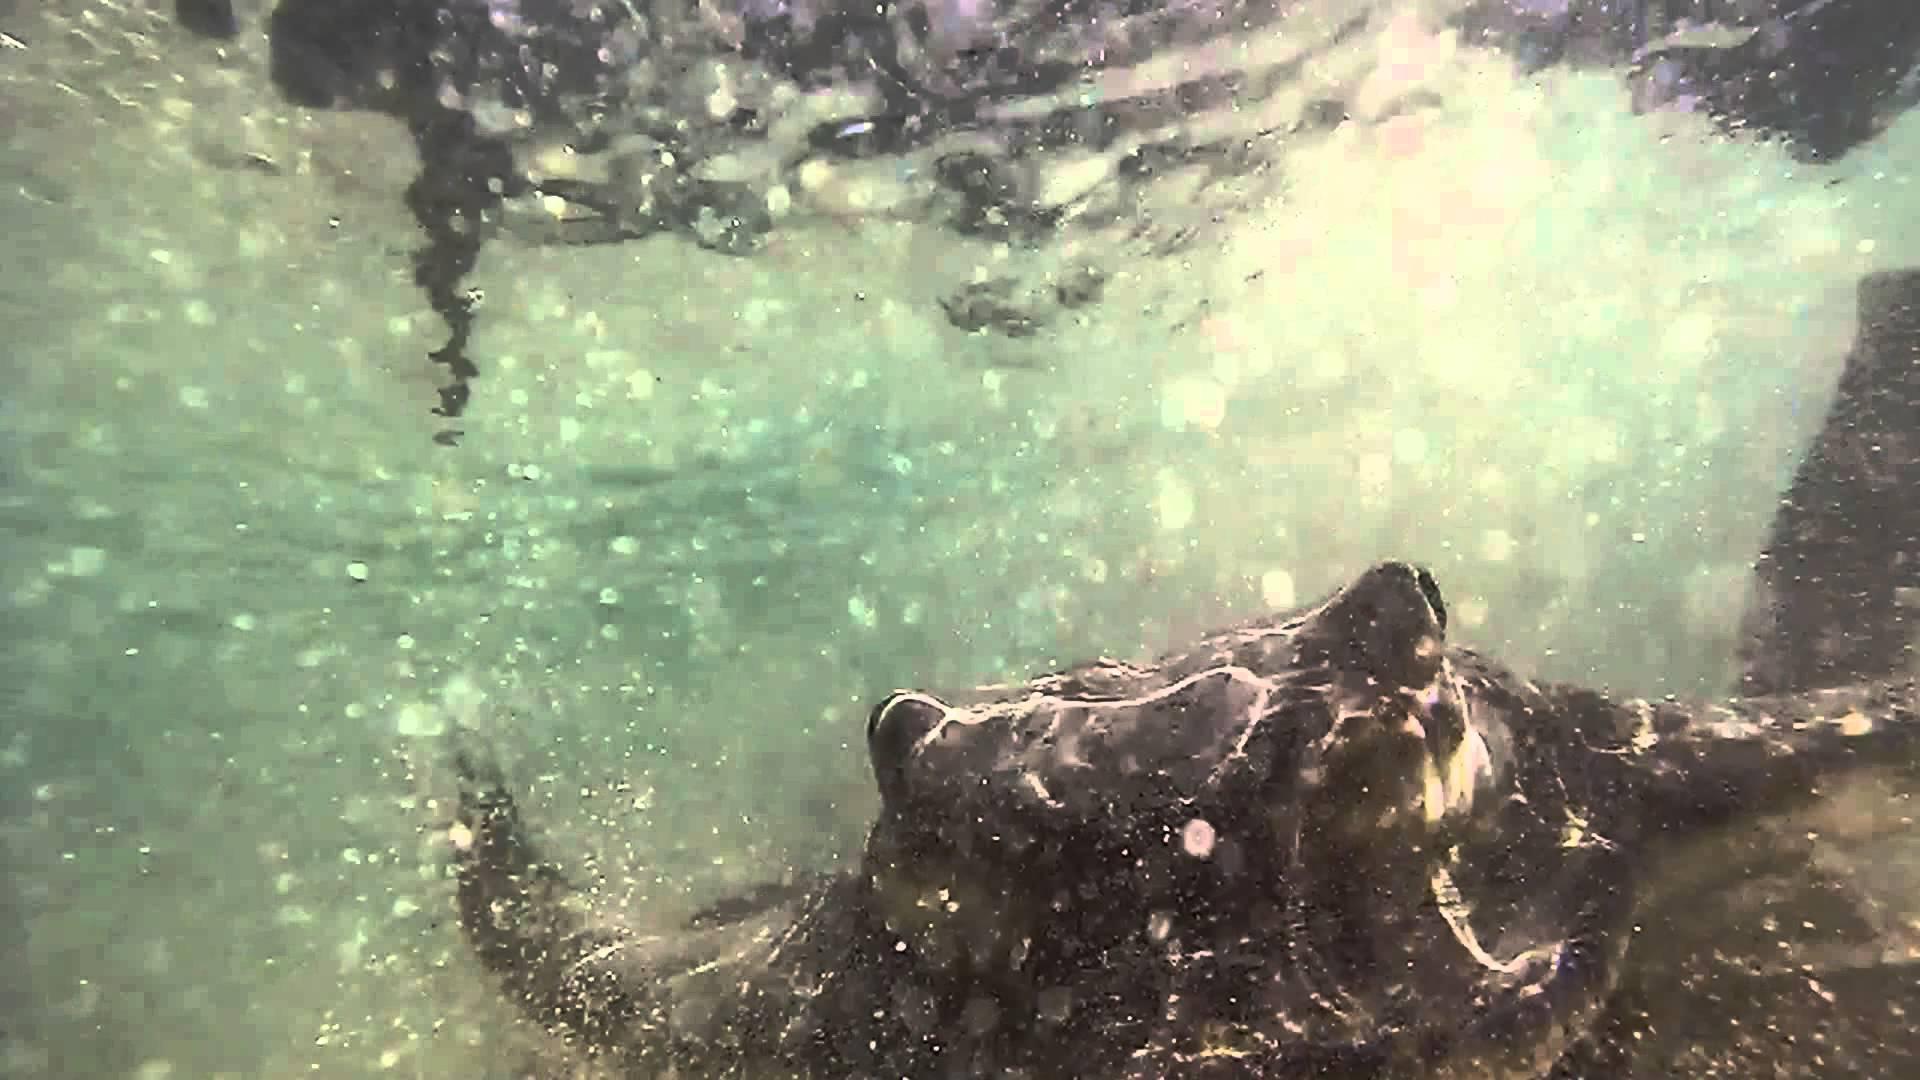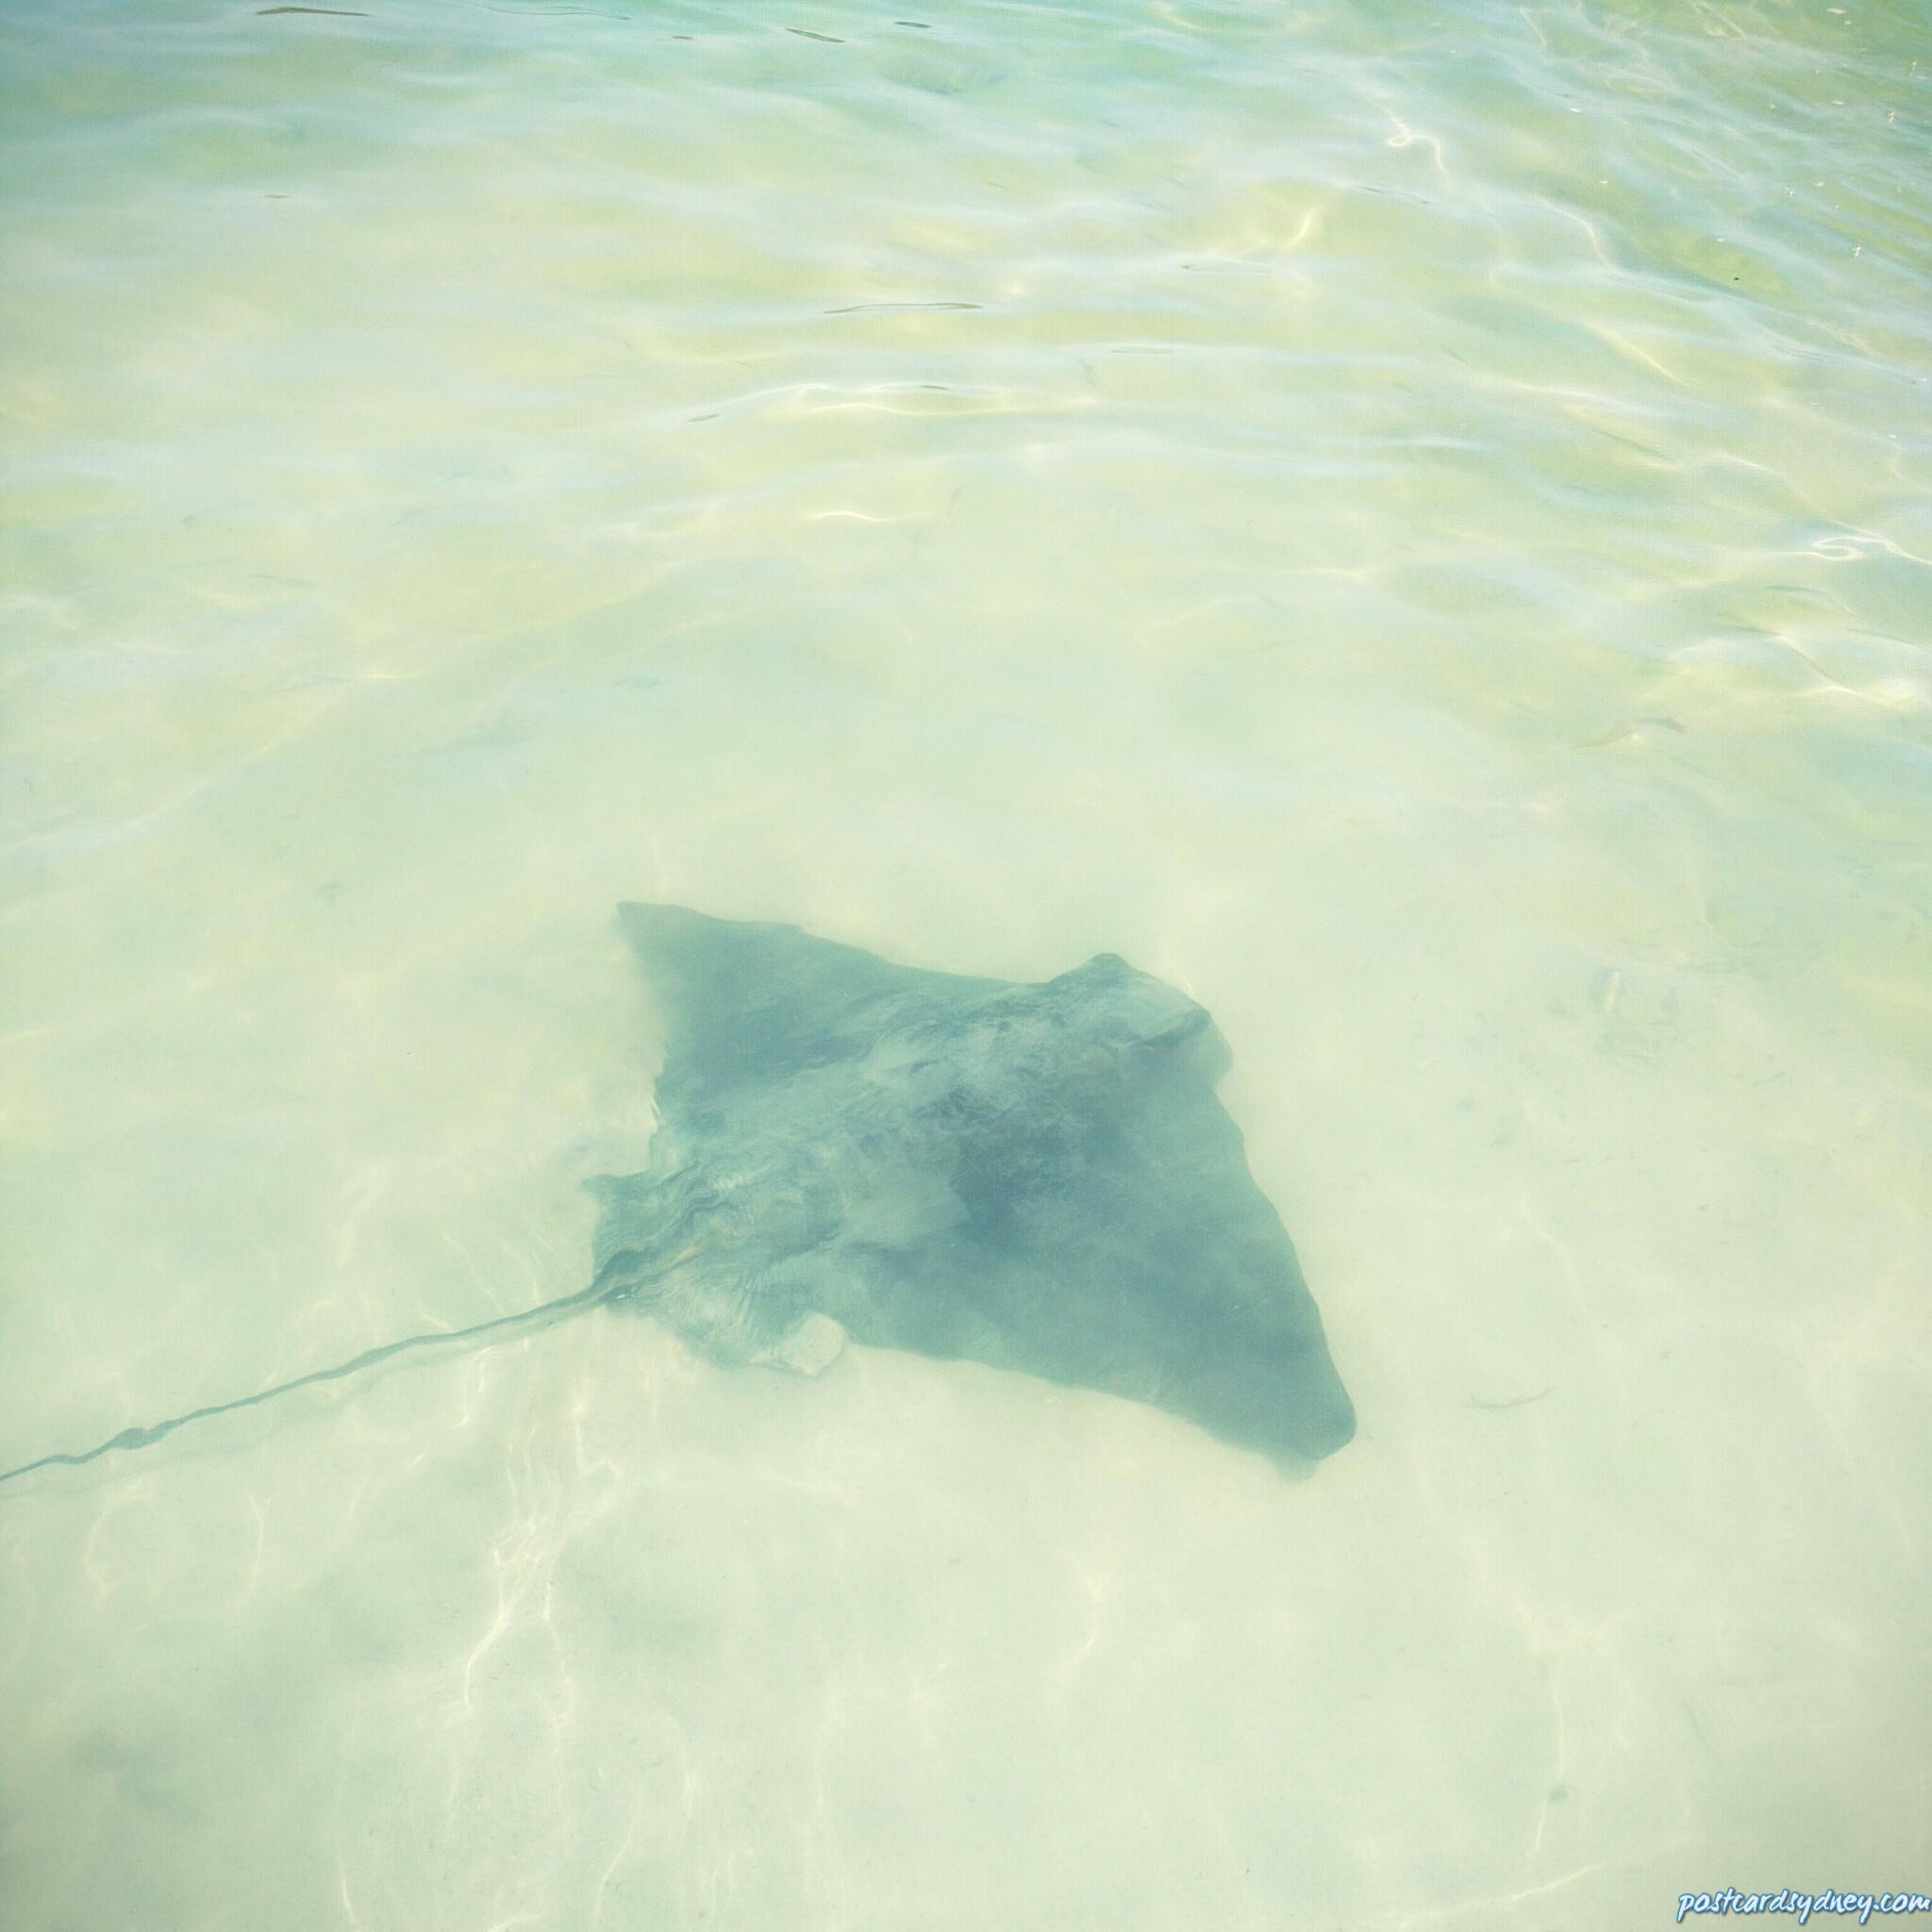The first image is the image on the left, the second image is the image on the right. Examine the images to the left and right. Is the description "A man is interacting with a sea animal in the water." accurate? Answer yes or no. No. The first image is the image on the left, the second image is the image on the right. Assess this claim about the two images: "An image shows one man standing in water and bending toward a stingray.". Correct or not? Answer yes or no. No. 